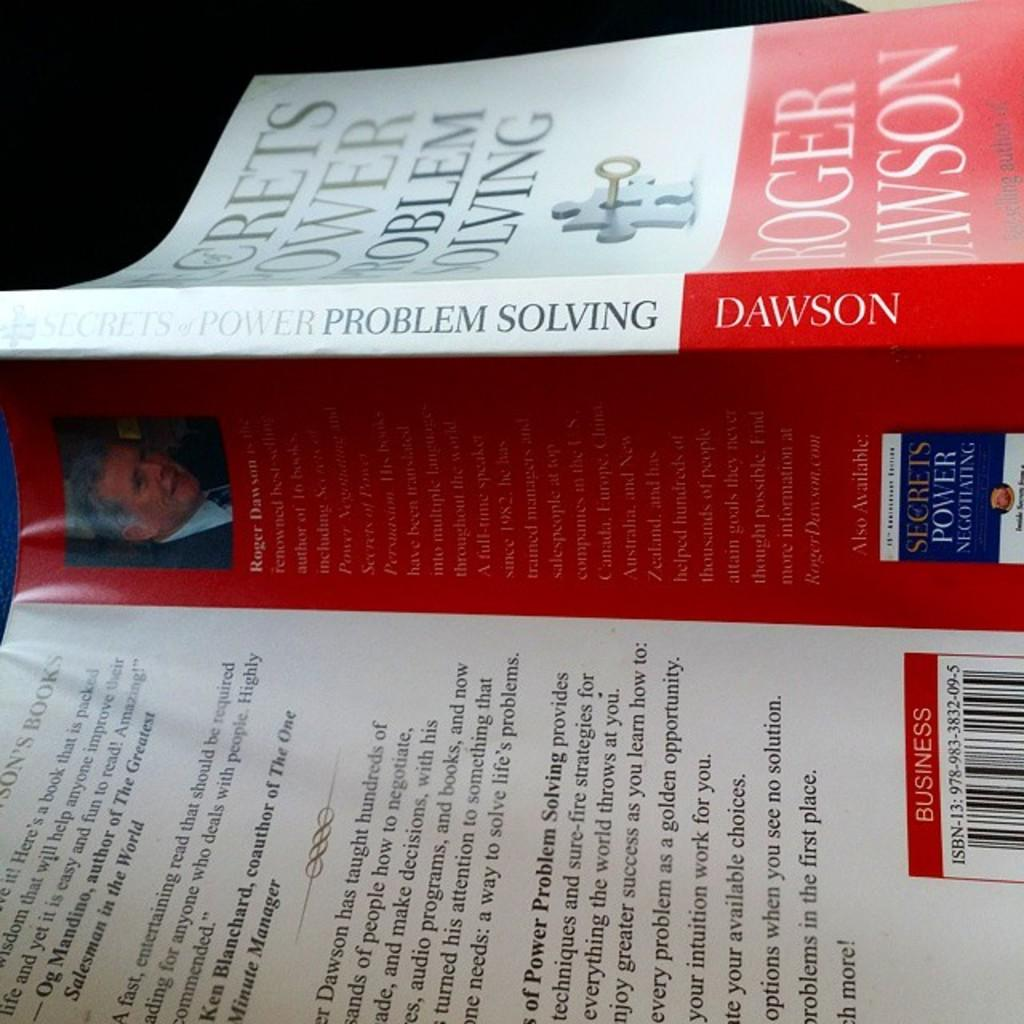What object is present in the image? There is a book in the image. What colors are featured on the book? The book has red and white colors. Is there any image on the book? Yes, there is a person's picture on the book. Where is the person's picture located on the book? The person's picture is on the left side of the book. How many bats are flying around the book in the image? There are no bats present in the image. Is there any dust visible on the book in the image? The provided facts do not mention any dust on the book, so we cannot determine its presence from the image. 